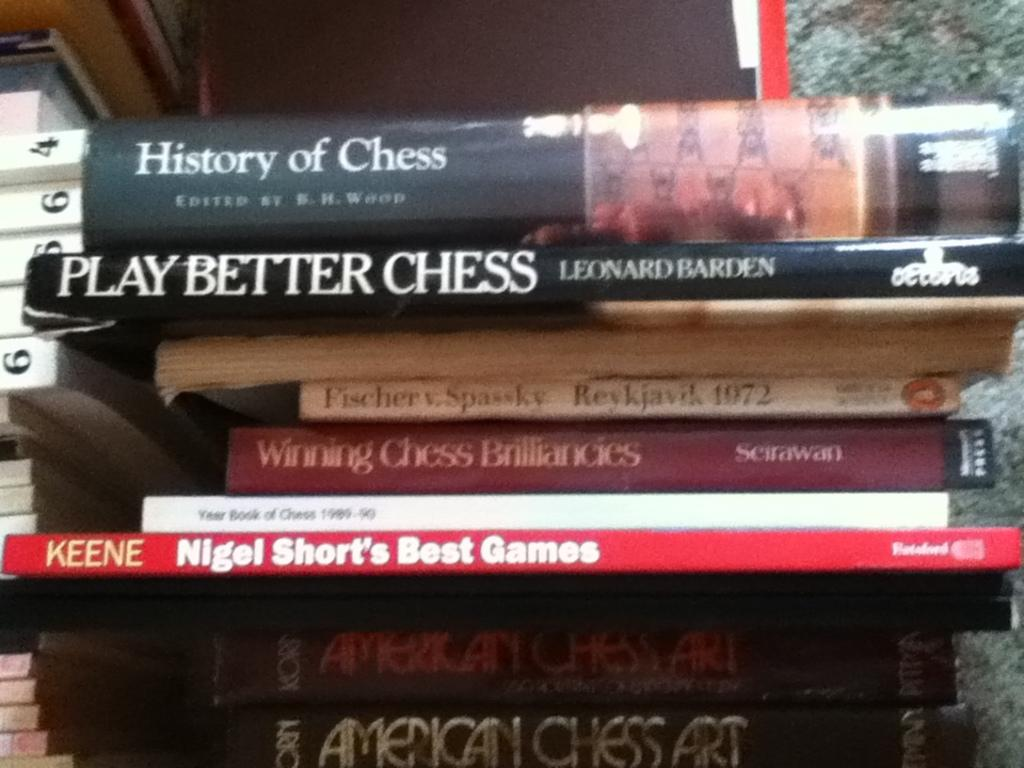<image>
Offer a succinct explanation of the picture presented. Winning Chess Brilliances book sits among a stack of books about chess 